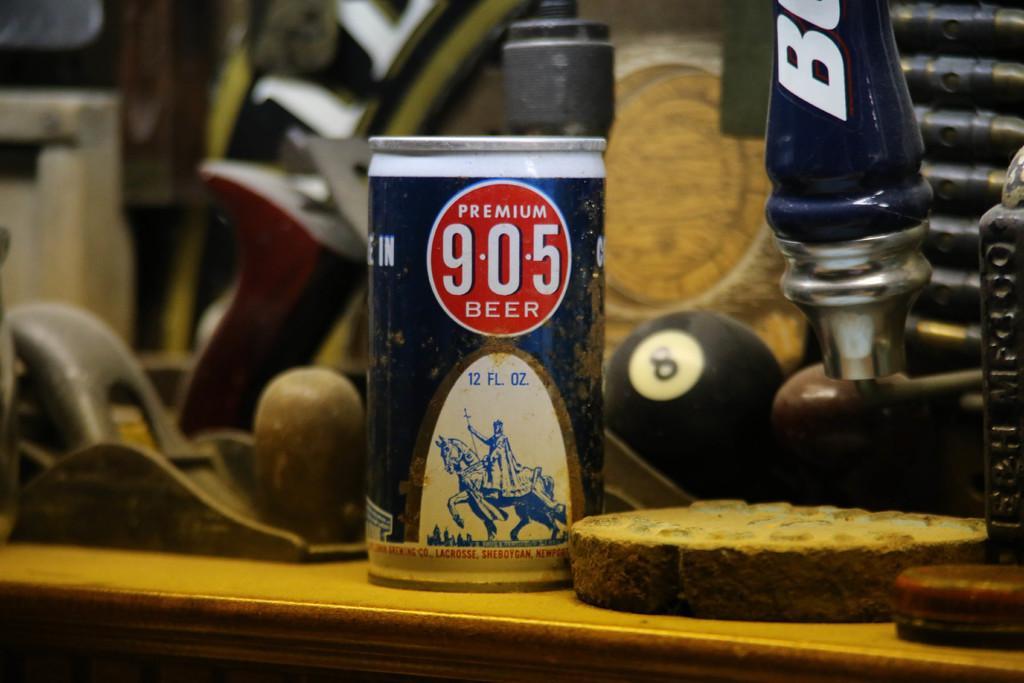Could you give a brief overview of what you see in this image? In this image we can see a group of objects on a table. In the foreground we can see a tin. On the tin we can see a label and the label consists of some text and image. 